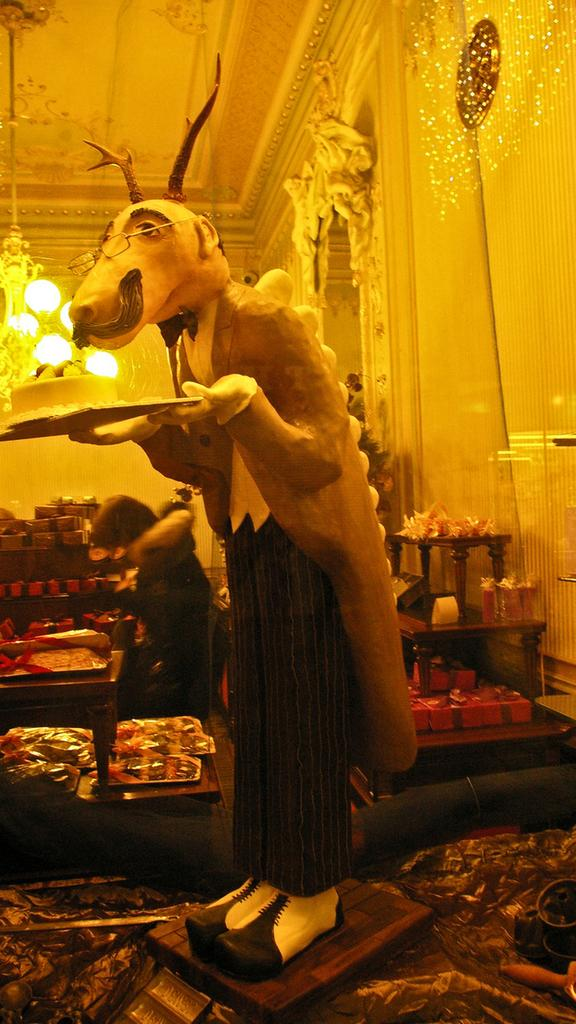What is the main subject in the image? There is a statue in the image. What other objects can be seen in the image? There are trays, gift boxes, a chandelier, lights, a wall, and a person standing in the image. Can you describe the chandelier in the image? The chandelier is a decorative light fixture that hangs from the ceiling. What type of objects might be placed on the trays in the image? The trays could hold various items, such as food, drinks, or decorative objects. What is the person in the image doing? The person is standing in the image, but their specific actions or intentions are not clear. What type of sweater is the person wearing in the image? There is no sweater visible in the image; the person is not wearing any clothing. What is the zinc content of the gift boxes in the image? There is no information about the zinc content of the gift boxes in the image, as this detail is not relevant to the visual content. What type of linen is used to cover the statue in the image? There is no linen covering the statue in the image; the statue is visible and not obscured by any fabric. 